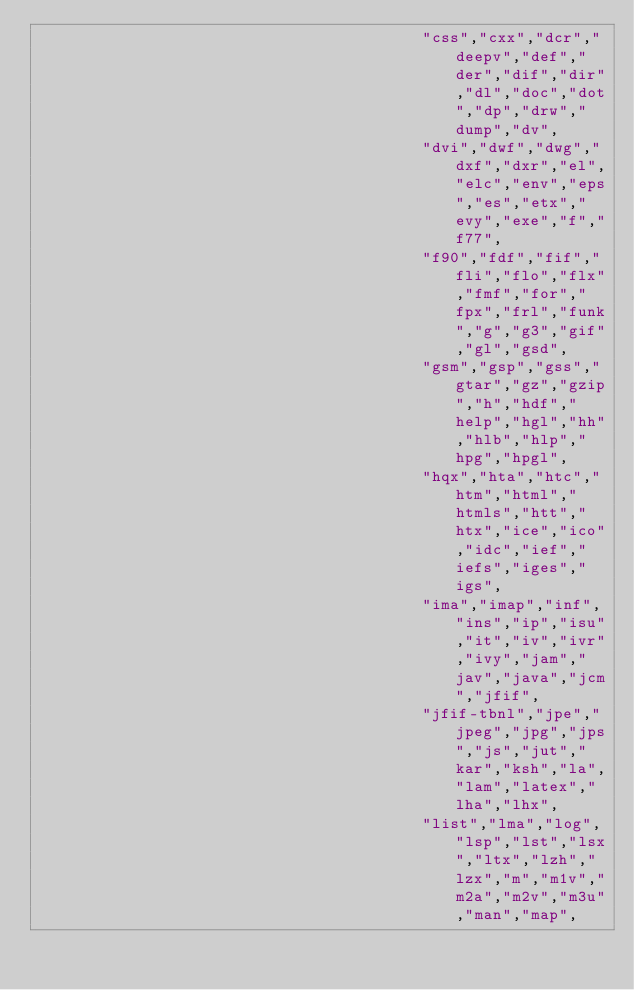Convert code to text. <code><loc_0><loc_0><loc_500><loc_500><_Scala_>                                         "css","cxx","dcr","deepv","def","der","dif","dir","dl","doc","dot","dp","drw","dump","dv",
                                         "dvi","dwf","dwg","dxf","dxr","el","elc","env","eps","es","etx","evy","exe","f","f77",
                                         "f90","fdf","fif","fli","flo","flx","fmf","for","fpx","frl","funk","g","g3","gif","gl","gsd",
                                         "gsm","gsp","gss","gtar","gz","gzip","h","hdf","help","hgl","hh","hlb","hlp","hpg","hpgl",
                                         "hqx","hta","htc","htm","html","htmls","htt","htx","ice","ico","idc","ief","iefs","iges","igs",
                                         "ima","imap","inf","ins","ip","isu","it","iv","ivr","ivy","jam","jav","java","jcm","jfif",
                                         "jfif-tbnl","jpe","jpeg","jpg","jps","js","jut","kar","ksh","la","lam","latex","lha","lhx",
                                         "list","lma","log","lsp","lst","lsx","ltx","lzh","lzx","m","m1v","m2a","m2v","m3u","man","map",</code> 